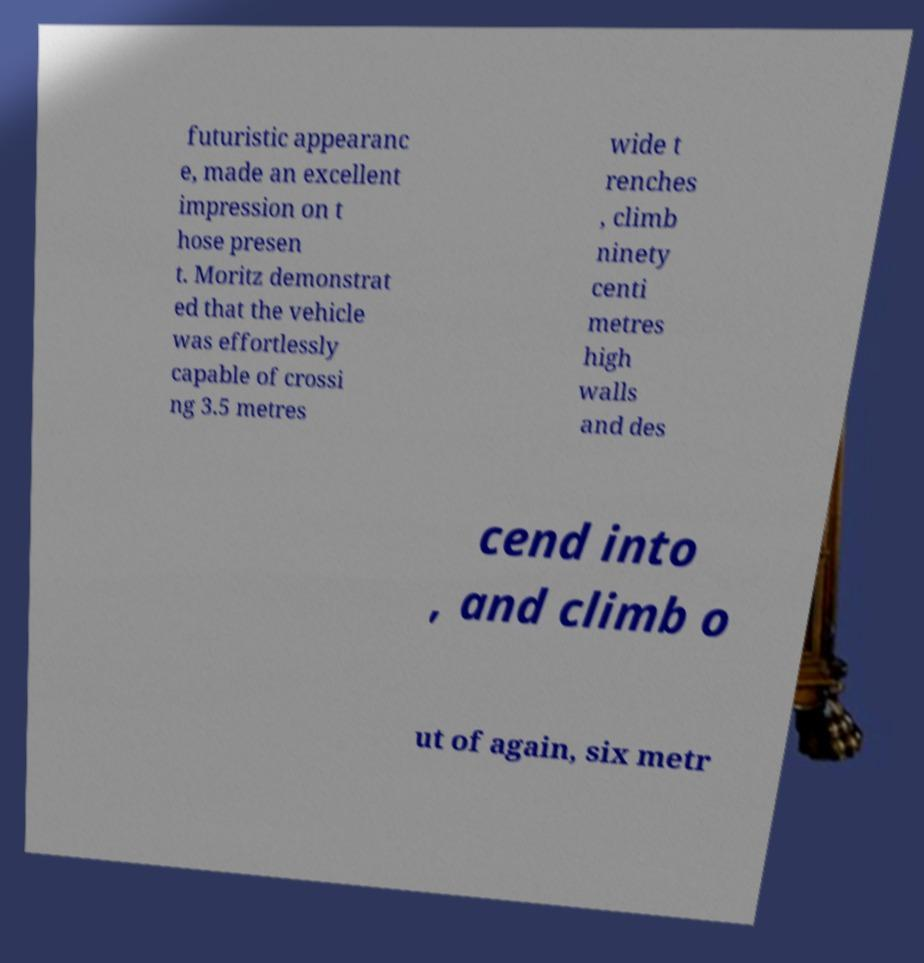Could you extract and type out the text from this image? futuristic appearanc e, made an excellent impression on t hose presen t. Moritz demonstrat ed that the vehicle was effortlessly capable of crossi ng 3.5 metres wide t renches , climb ninety centi metres high walls and des cend into , and climb o ut of again, six metr 